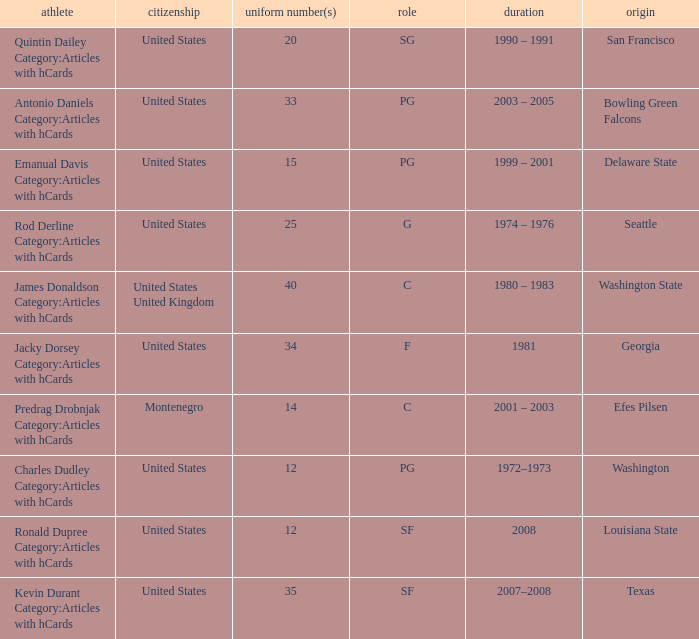Could you help me parse every detail presented in this table? {'header': ['athlete', 'citizenship', 'uniform number(s)', 'role', 'duration', 'origin'], 'rows': [['Quintin Dailey Category:Articles with hCards', 'United States', '20', 'SG', '1990 – 1991', 'San Francisco'], ['Antonio Daniels Category:Articles with hCards', 'United States', '33', 'PG', '2003 – 2005', 'Bowling Green Falcons'], ['Emanual Davis Category:Articles with hCards', 'United States', '15', 'PG', '1999 – 2001', 'Delaware State'], ['Rod Derline Category:Articles with hCards', 'United States', '25', 'G', '1974 – 1976', 'Seattle'], ['James Donaldson Category:Articles with hCards', 'United States United Kingdom', '40', 'C', '1980 – 1983', 'Washington State'], ['Jacky Dorsey Category:Articles with hCards', 'United States', '34', 'F', '1981', 'Georgia'], ['Predrag Drobnjak Category:Articles with hCards', 'Montenegro', '14', 'C', '2001 – 2003', 'Efes Pilsen'], ['Charles Dudley Category:Articles with hCards', 'United States', '12', 'PG', '1972–1973', 'Washington'], ['Ronald Dupree Category:Articles with hCards', 'United States', '12', 'SF', '2008', 'Louisiana State'], ['Kevin Durant Category:Articles with hCards', 'United States', '35', 'SF', '2007–2008', 'Texas']]} What is the lowest jersey number of a player from louisiana state? 12.0. 